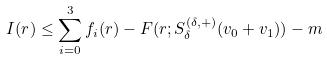<formula> <loc_0><loc_0><loc_500><loc_500>I ( r ) \leq \sum _ { i = 0 } ^ { 3 } f _ { i } ( r ) - F ( r ; S ^ { ( \delta , + ) } _ { \delta } ( v _ { 0 } + v _ { 1 } ) ) - m</formula> 